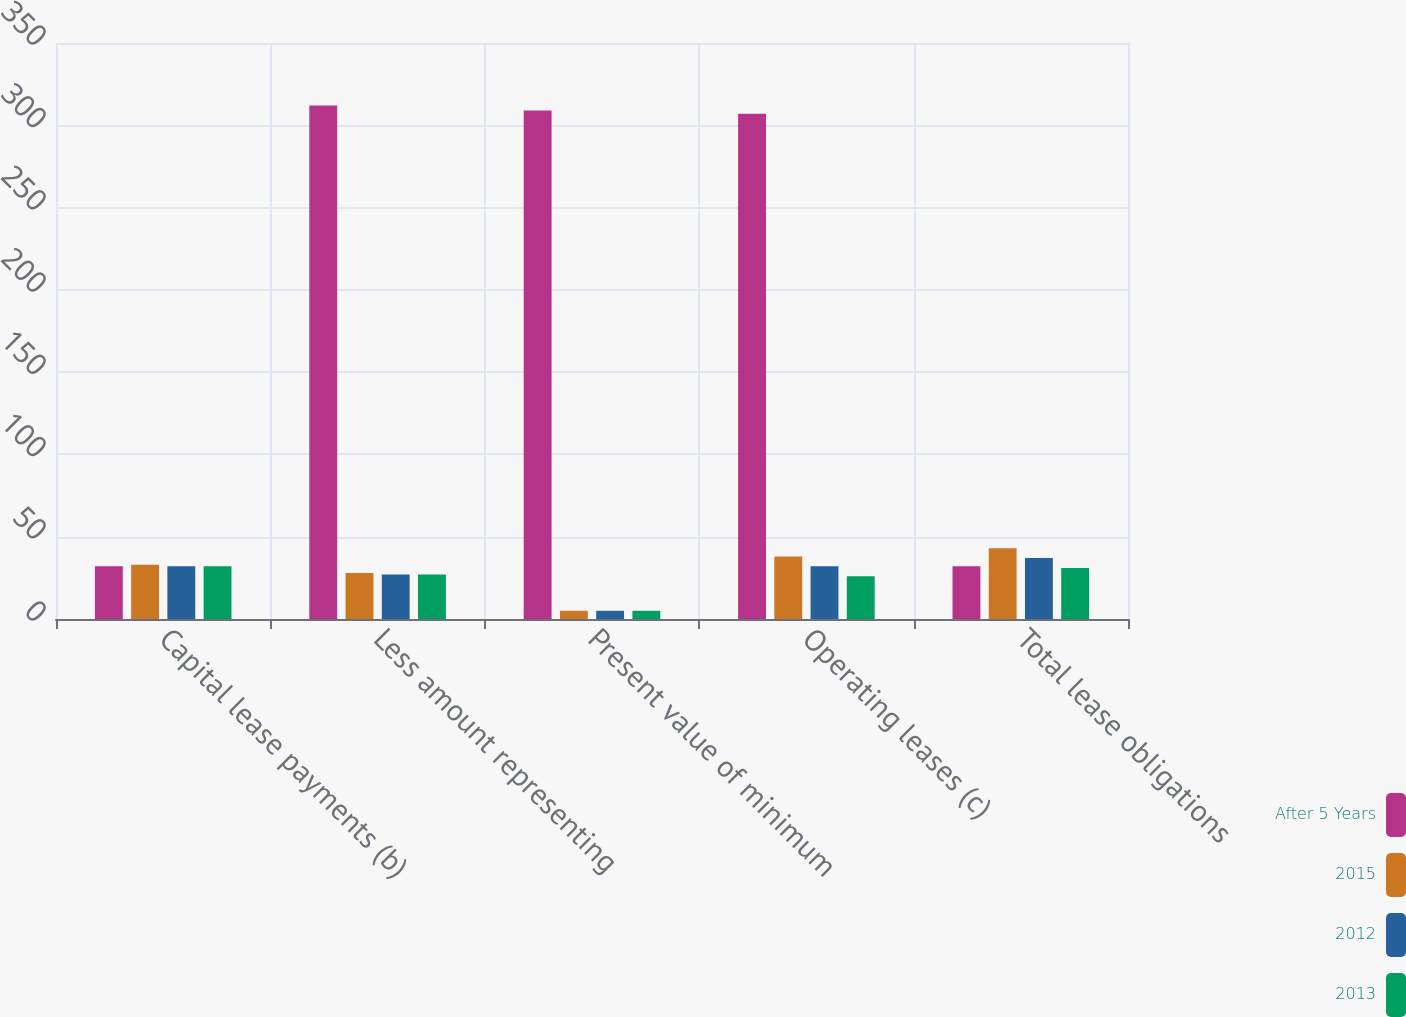<chart> <loc_0><loc_0><loc_500><loc_500><stacked_bar_chart><ecel><fcel>Capital lease payments (b)<fcel>Less amount representing<fcel>Present value of minimum<fcel>Operating leases (c)<fcel>Total lease obligations<nl><fcel>After 5 Years<fcel>32<fcel>312<fcel>309<fcel>307<fcel>32<nl><fcel>2015<fcel>33<fcel>28<fcel>5<fcel>38<fcel>43<nl><fcel>2012<fcel>32<fcel>27<fcel>5<fcel>32<fcel>37<nl><fcel>2013<fcel>32<fcel>27<fcel>5<fcel>26<fcel>31<nl></chart> 